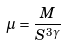Convert formula to latex. <formula><loc_0><loc_0><loc_500><loc_500>\mu = \frac { M } { S ^ { 3 \gamma } }</formula> 